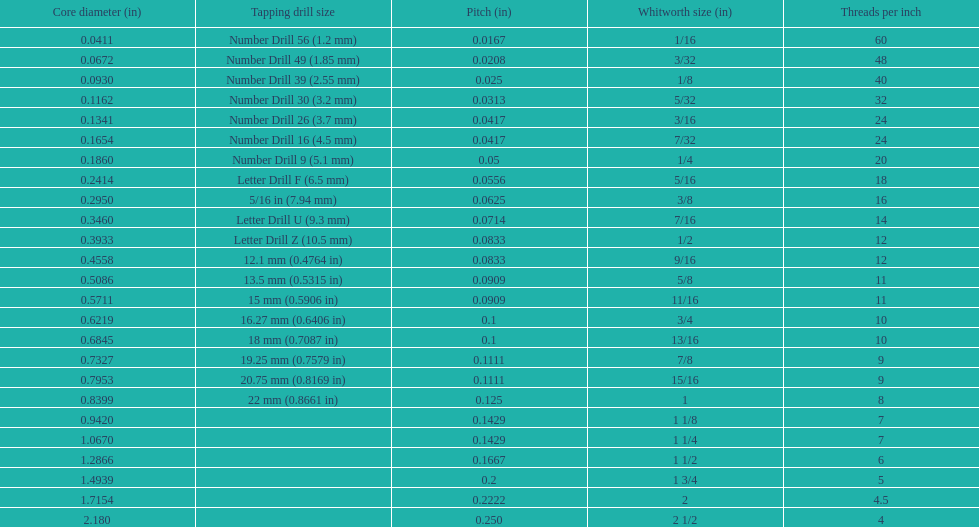What is the least core diameter (in)? 0.0411. 